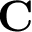<formula> <loc_0><loc_0><loc_500><loc_500>C</formula> 